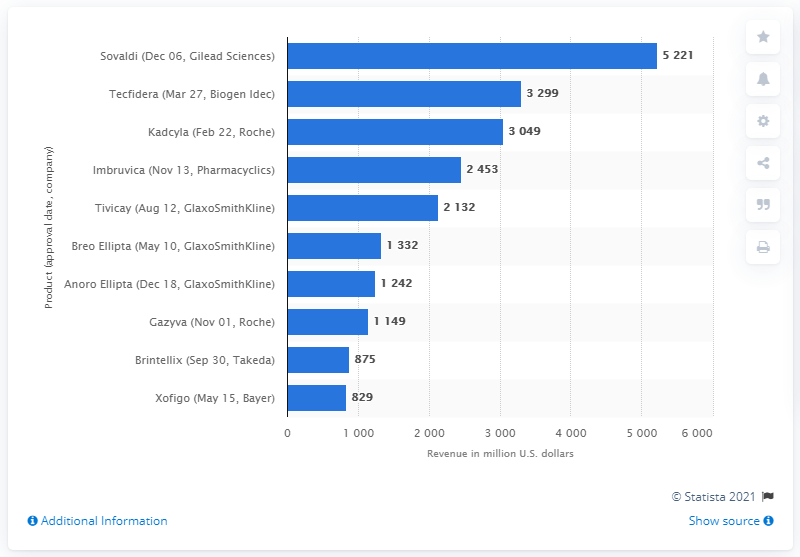Point out several critical features in this image. The largest bar of drug Sovaldi was produced by Gilead Sciences on December 06. The revenue ratio between xofigo and Sovaldi is 0.158781843... 